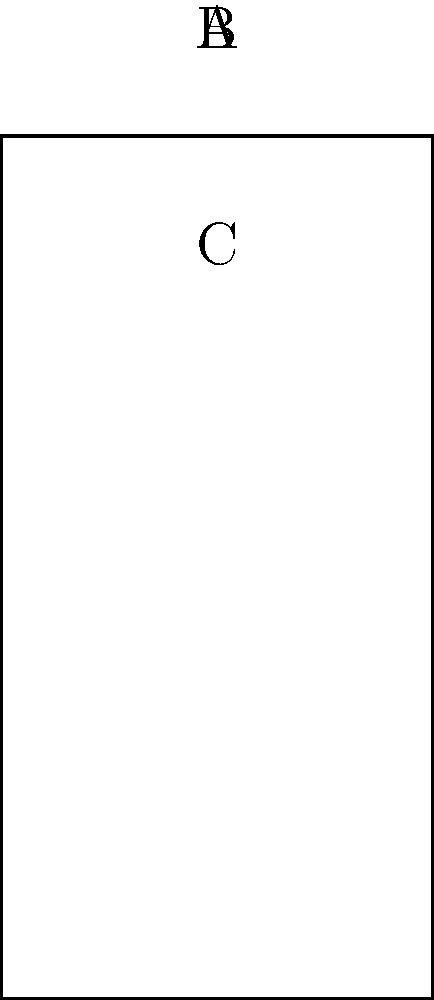As part of your water conservation club project, you're studying water pressure in different tank shapes. The image shows three water tanks with the same base area and water level. How do the pressures at the bottom of tanks A, B, and C compare? To understand the pressure distribution in these tanks, let's follow these steps:

1. Recall the hydrostatic pressure equation: $P = \rho gh$
   Where:
   $P$ = pressure
   $\rho$ = density of water
   $g$ = acceleration due to gravity
   $h$ = height of water column

2. Observe that all tanks have the same water level height.

3. The shape of the tank above the water level doesn't affect the pressure at the bottom.

4. The pressure at any point in a static fluid depends only on the depth below the surface and the fluid's density, not on the shape of the container.

5. Since $\rho$ and $g$ are constant, and $h$ is the same for all tanks, the pressure at the bottom of each tank will be equal.

6. The shape of the tank does affect the total force on the bottom (which is pressure multiplied by area), but not the pressure itself.

Therefore, despite the different shapes of the tanks, the pressure at the bottom (P_A, P_B, and P_C) will be equal in all three tanks.
Answer: $P_A = P_B = P_C$ 